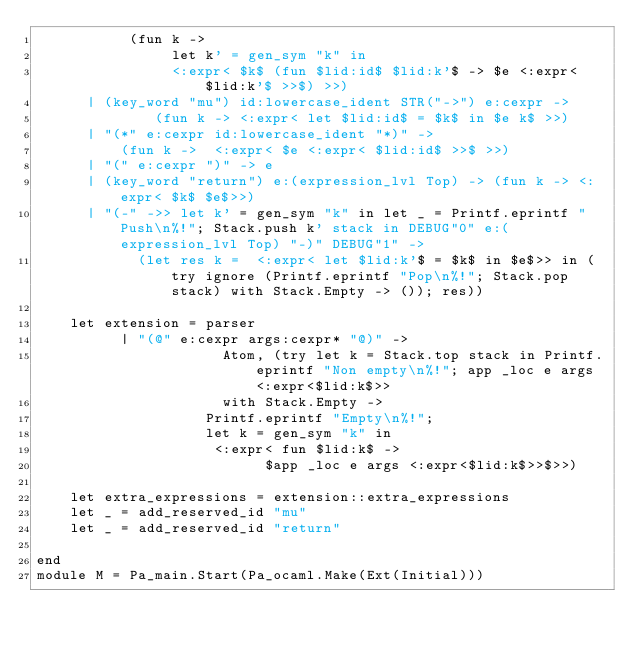<code> <loc_0><loc_0><loc_500><loc_500><_OCaml_>	       (fun k ->
			    let k' = gen_sym "k" in
  		        <:expr< $k$ (fun $lid:id$ $lid:k'$ -> $e <:expr< $lid:k'$ >>$) >>)
 	  | (key_word "mu") id:lowercase_ident STR("->") e:cexpr ->
              (fun k -> <:expr< let $lid:id$ = $k$ in $e k$ >>)
	  | "(*" e:cexpr id:lowercase_ident "*)" ->
	      (fun k ->  <:expr< $e <:expr< $lid:id$ >>$ >>)
	  | "(" e:cexpr ")" -> e
	  | (key_word "return") e:(expression_lvl Top) -> (fun k -> <:expr< $k$ $e$>>)			 
	  | "(-" ->> let k' = gen_sym "k" in let _ = Printf.eprintf "Push\n%!"; Stack.push k' stack in DEBUG"0" e:(expression_lvl Top) "-)" DEBUG"1" ->
			(let res k =  <:expr< let $lid:k'$ = $k$ in $e$>> in (try ignore (Printf.eprintf "Pop\n%!"; Stack.pop stack) with Stack.Empty -> ()); res))
		   
    let extension = parser
		  | "(@" e:cexpr args:cexpr* "@)" ->
				      Atom, (try let k = Stack.top stack in Printf.eprintf "Non empty\n%!"; app _loc e args <:expr<$lid:k$>>
				      with Stack.Empty ->
					Printf.eprintf "Empty\n%!";
					let k = gen_sym "k" in
					 <:expr< fun $lid:k$ -> 
					       $app _loc e args <:expr<$lid:k$>>$>>)

    let extra_expressions = extension::extra_expressions
    let _ = add_reserved_id "mu"
    let _ = add_reserved_id "return"

end
module M = Pa_main.Start(Pa_ocaml.Make(Ext(Initial)))
</code> 